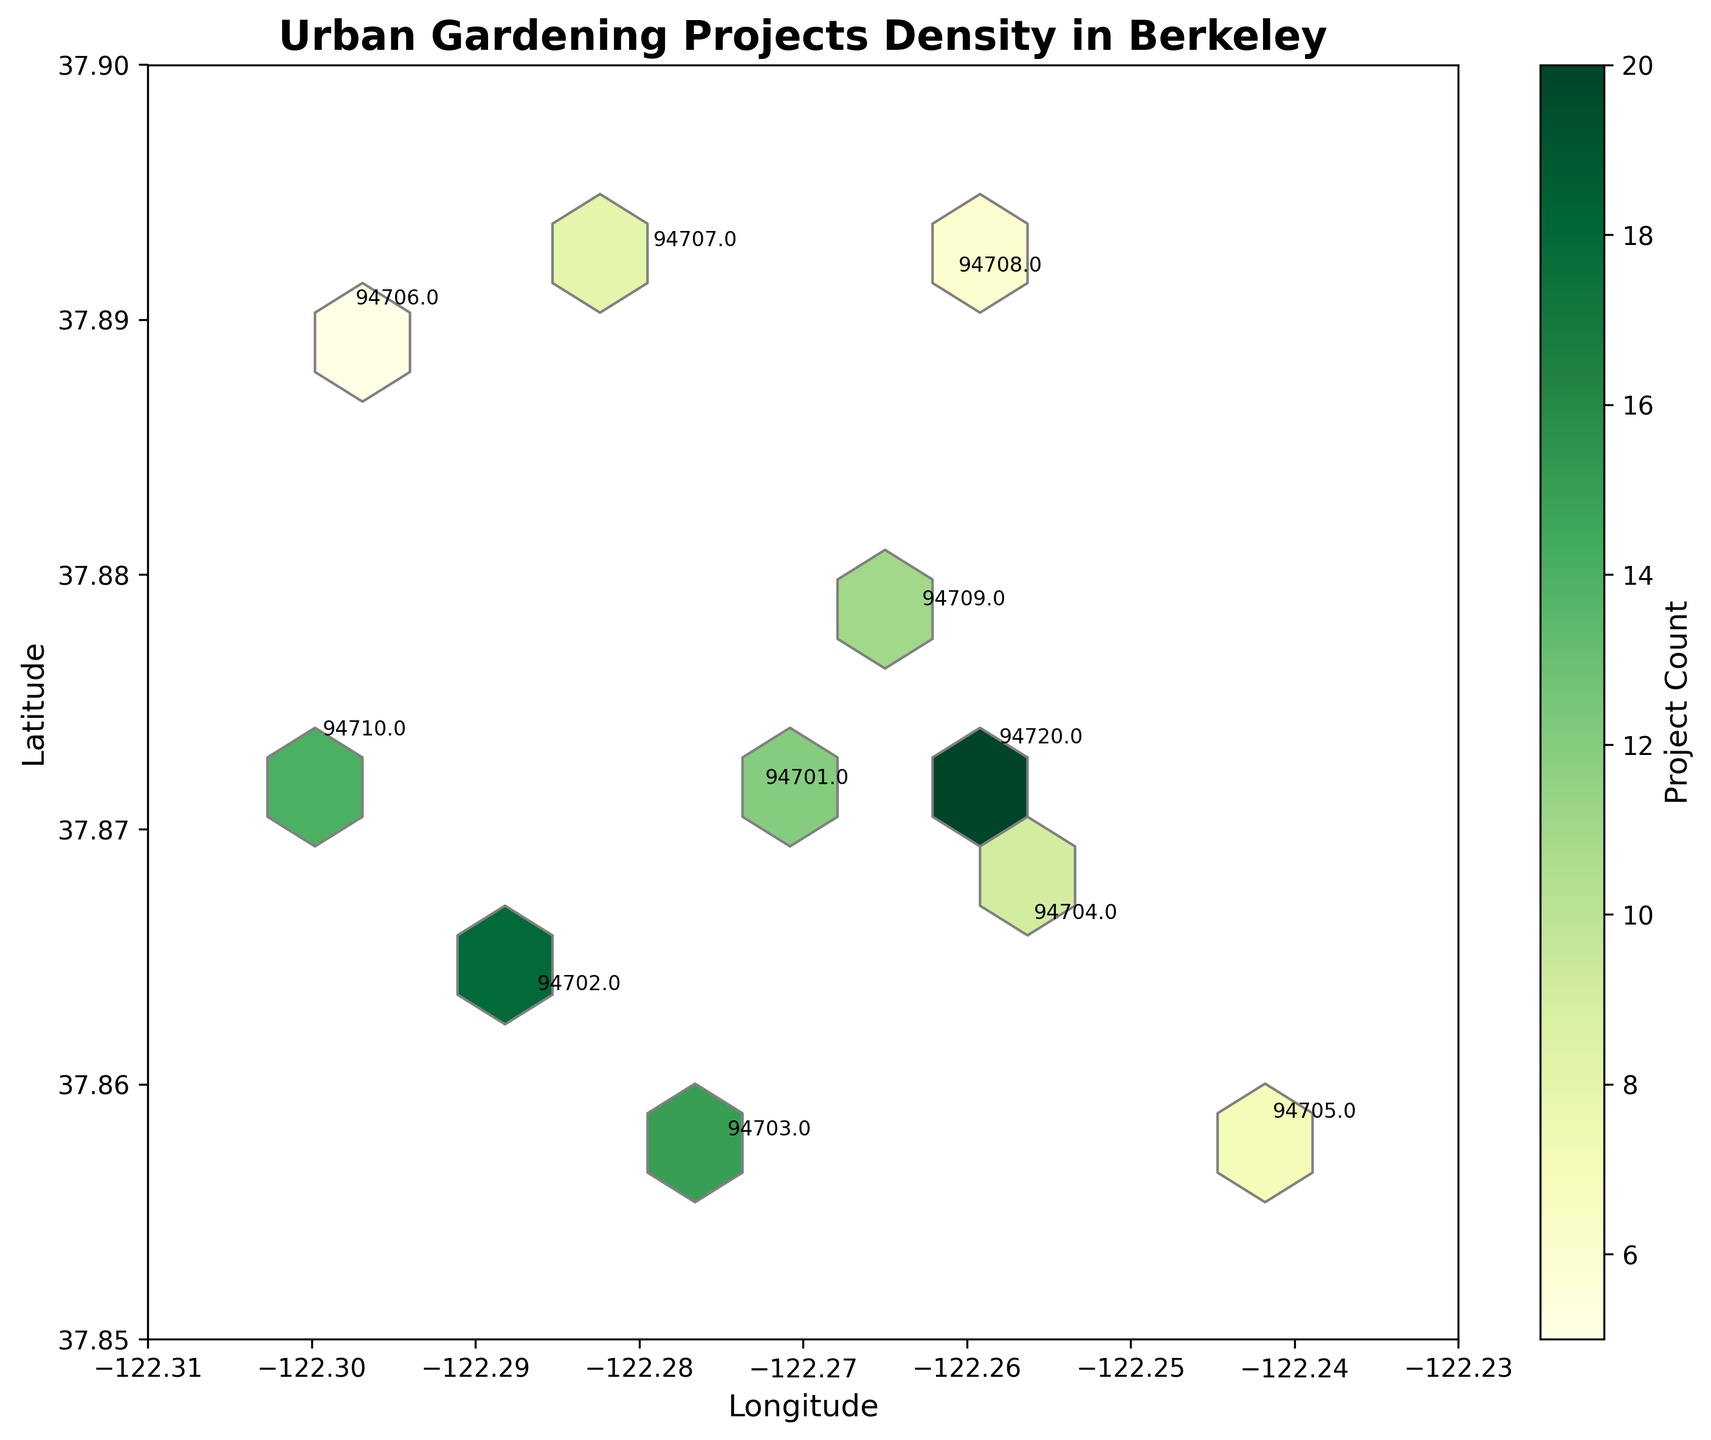What is the title of the figure? Look at the top of the figure for the title. The title is "Urban Gardening Projects Density in Berkeley".
Answer: Urban Gardening Projects Density in Berkeley What does the colorbar represent? Observe the colorbar on the side, which often labels what the color intensity stands for in the plot. The label reads "Project Count".
Answer: Project Count Which zip code has the highest project count? Look for the zip code with the highest color intensity in the hexbin plot or annotated numbers. 94720 has the highest project count with 20 projects.
Answer: 94720 What is the range of latitude in the plot? Check the y-axis for the minimum and maximum values. The y-axis ranges from approximately 37.85 to 37.90.
Answer: 37.85 to 37.90 Which zip code has the lowest project count? Identify the zip code with the lightest color in the plot or annotated numbers. 94706 has the lowest project count with 5 projects.
Answer: 94706 How is the project density distributed around the longitude -122.27? Identify the hexagons around -122.27 and observe their color intensity. High project density is observed near zip code 94701 (12 projects) and 94703 (15 projects).
Answer: High near 94701 and 94703 What is the project count difference between zip codes 94702 and 94704? Subtract the project count of 94704 from 94702. 94702 has 18 projects and 94704 has 9 projects. So, 18 - 9 = 9.
Answer: 9 Which zip codes have a project count between 6 and 15? Look at the annotated numbers and identify zip codes with a project count in this range. Zip codes 94701, 94703, 94707, 94708, 94709, and 94710 are all in this range.
Answer: 94701, 94703, 94707, 94708, 94709, 94710 Is there any area with sparse project density? Observe if there are large areas with light colors or no shaded hexagons. The area around zip code 94706 appears sparse with only 5 projects.
Answer: Yes, around 94706 How many zip codes are annotated in the plot? Count the number of unique zip codes annotated on the plot. There are annotations for 11 zip codes.
Answer: 11 